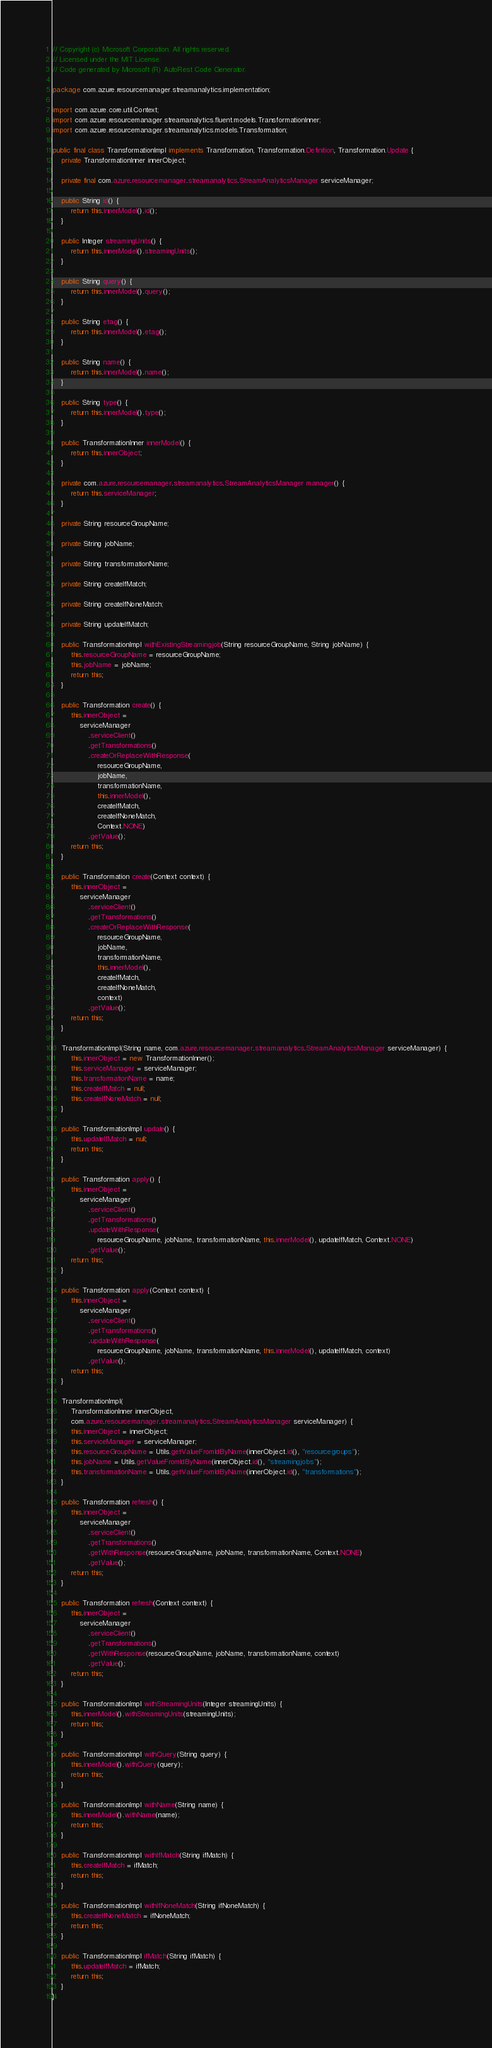<code> <loc_0><loc_0><loc_500><loc_500><_Java_>// Copyright (c) Microsoft Corporation. All rights reserved.
// Licensed under the MIT License.
// Code generated by Microsoft (R) AutoRest Code Generator.

package com.azure.resourcemanager.streamanalytics.implementation;

import com.azure.core.util.Context;
import com.azure.resourcemanager.streamanalytics.fluent.models.TransformationInner;
import com.azure.resourcemanager.streamanalytics.models.Transformation;

public final class TransformationImpl implements Transformation, Transformation.Definition, Transformation.Update {
    private TransformationInner innerObject;

    private final com.azure.resourcemanager.streamanalytics.StreamAnalyticsManager serviceManager;

    public String id() {
        return this.innerModel().id();
    }

    public Integer streamingUnits() {
        return this.innerModel().streamingUnits();
    }

    public String query() {
        return this.innerModel().query();
    }

    public String etag() {
        return this.innerModel().etag();
    }

    public String name() {
        return this.innerModel().name();
    }

    public String type() {
        return this.innerModel().type();
    }

    public TransformationInner innerModel() {
        return this.innerObject;
    }

    private com.azure.resourcemanager.streamanalytics.StreamAnalyticsManager manager() {
        return this.serviceManager;
    }

    private String resourceGroupName;

    private String jobName;

    private String transformationName;

    private String createIfMatch;

    private String createIfNoneMatch;

    private String updateIfMatch;

    public TransformationImpl withExistingStreamingjob(String resourceGroupName, String jobName) {
        this.resourceGroupName = resourceGroupName;
        this.jobName = jobName;
        return this;
    }

    public Transformation create() {
        this.innerObject =
            serviceManager
                .serviceClient()
                .getTransformations()
                .createOrReplaceWithResponse(
                    resourceGroupName,
                    jobName,
                    transformationName,
                    this.innerModel(),
                    createIfMatch,
                    createIfNoneMatch,
                    Context.NONE)
                .getValue();
        return this;
    }

    public Transformation create(Context context) {
        this.innerObject =
            serviceManager
                .serviceClient()
                .getTransformations()
                .createOrReplaceWithResponse(
                    resourceGroupName,
                    jobName,
                    transformationName,
                    this.innerModel(),
                    createIfMatch,
                    createIfNoneMatch,
                    context)
                .getValue();
        return this;
    }

    TransformationImpl(String name, com.azure.resourcemanager.streamanalytics.StreamAnalyticsManager serviceManager) {
        this.innerObject = new TransformationInner();
        this.serviceManager = serviceManager;
        this.transformationName = name;
        this.createIfMatch = null;
        this.createIfNoneMatch = null;
    }

    public TransformationImpl update() {
        this.updateIfMatch = null;
        return this;
    }

    public Transformation apply() {
        this.innerObject =
            serviceManager
                .serviceClient()
                .getTransformations()
                .updateWithResponse(
                    resourceGroupName, jobName, transformationName, this.innerModel(), updateIfMatch, Context.NONE)
                .getValue();
        return this;
    }

    public Transformation apply(Context context) {
        this.innerObject =
            serviceManager
                .serviceClient()
                .getTransformations()
                .updateWithResponse(
                    resourceGroupName, jobName, transformationName, this.innerModel(), updateIfMatch, context)
                .getValue();
        return this;
    }

    TransformationImpl(
        TransformationInner innerObject,
        com.azure.resourcemanager.streamanalytics.StreamAnalyticsManager serviceManager) {
        this.innerObject = innerObject;
        this.serviceManager = serviceManager;
        this.resourceGroupName = Utils.getValueFromIdByName(innerObject.id(), "resourcegroups");
        this.jobName = Utils.getValueFromIdByName(innerObject.id(), "streamingjobs");
        this.transformationName = Utils.getValueFromIdByName(innerObject.id(), "transformations");
    }

    public Transformation refresh() {
        this.innerObject =
            serviceManager
                .serviceClient()
                .getTransformations()
                .getWithResponse(resourceGroupName, jobName, transformationName, Context.NONE)
                .getValue();
        return this;
    }

    public Transformation refresh(Context context) {
        this.innerObject =
            serviceManager
                .serviceClient()
                .getTransformations()
                .getWithResponse(resourceGroupName, jobName, transformationName, context)
                .getValue();
        return this;
    }

    public TransformationImpl withStreamingUnits(Integer streamingUnits) {
        this.innerModel().withStreamingUnits(streamingUnits);
        return this;
    }

    public TransformationImpl withQuery(String query) {
        this.innerModel().withQuery(query);
        return this;
    }

    public TransformationImpl withName(String name) {
        this.innerModel().withName(name);
        return this;
    }

    public TransformationImpl withIfMatch(String ifMatch) {
        this.createIfMatch = ifMatch;
        return this;
    }

    public TransformationImpl withIfNoneMatch(String ifNoneMatch) {
        this.createIfNoneMatch = ifNoneMatch;
        return this;
    }

    public TransformationImpl ifMatch(String ifMatch) {
        this.updateIfMatch = ifMatch;
        return this;
    }
}
</code> 